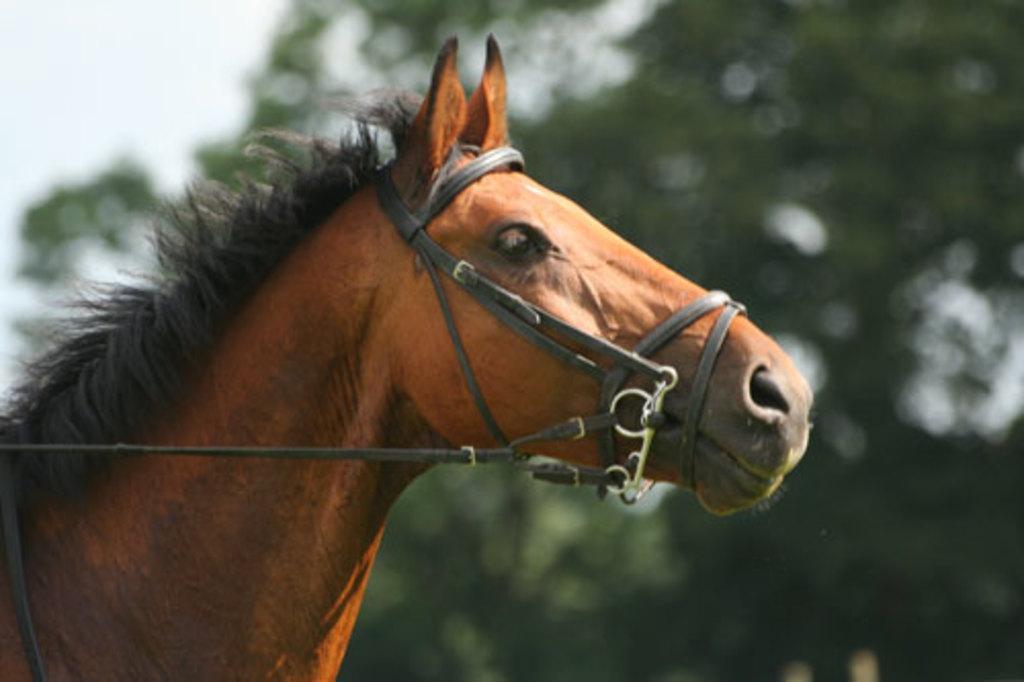Describe this image in one or two sentences. In this image I can see a horse which is brown and black in color and I can see it is tied with the belts which are black in color. In the background I can see the sky and few trees. 